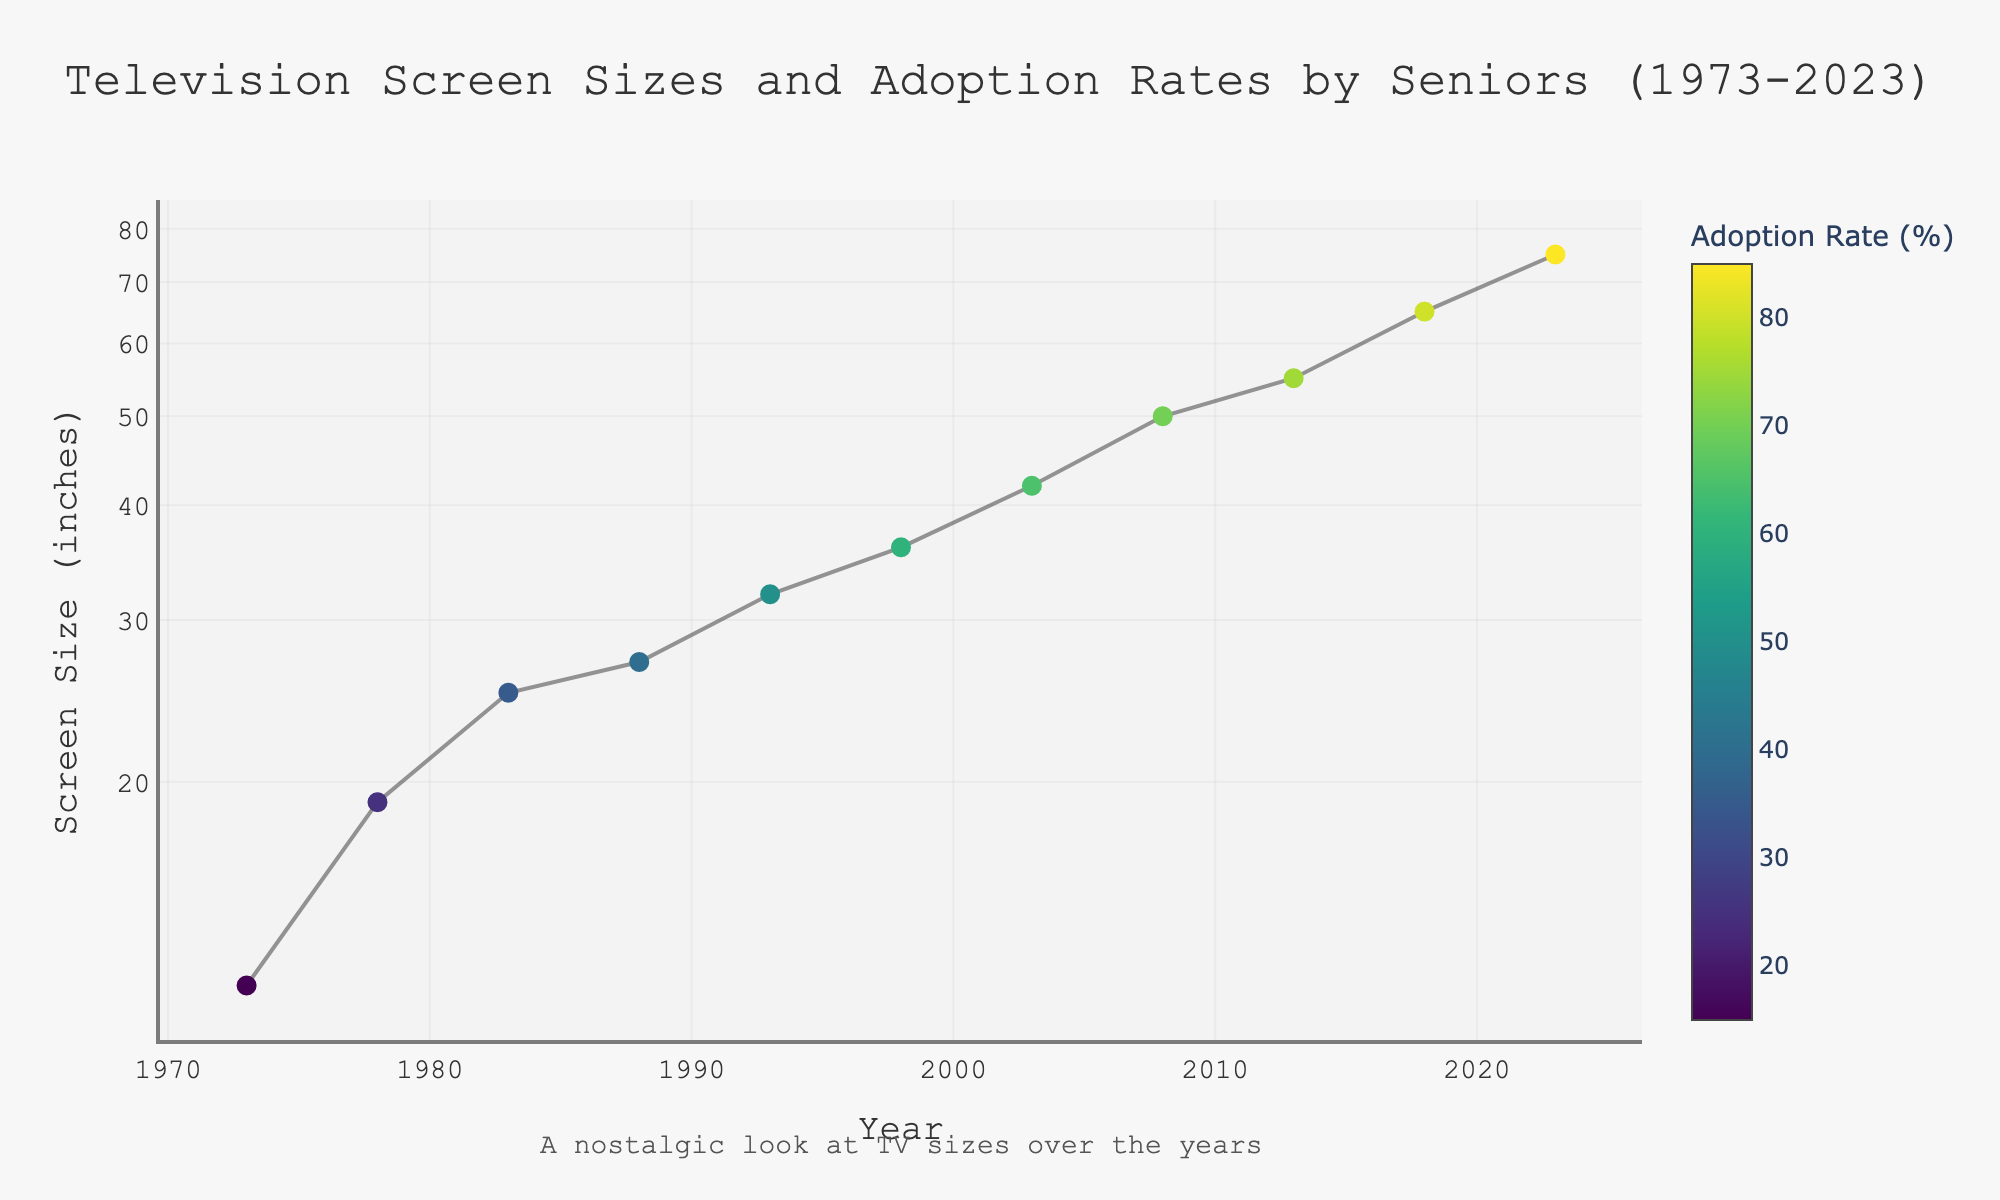what is the smallest screen size shown on the plot? The smallest screen size shown on the plot is the first data point in 1973, which corresponds to 12 inches.
Answer: 12 inches what does the color of the markers represent? The color of the markers represents the adoption rate by seniors, with darker colors indicating lower rates and brighter colors indicating higher rates.
Answer: Adoption rate by seniors how many total data points are shown in the plot? Observing the plot, there is one data point for each year listed, so the total number of data points corresponds to the dataset provided.
Answer: 11 what pattern can be observed between the screen size and the year progression? The plot shows that as the years progress from 1973 to 2023, the screen sizes increase. This indicates a trend of seniors adopting larger television screens over time.
Answer: Screen sizes increase over the years what is the adoption rate of seniors for a 50-inch screen? By locating the data point for a 50-inch screen size, which corresponds to the year 2008, the adoption rate is identified from the plot.
Answer: 70% how much did the screen size increase between 2003 and 2013? The screen size in 2003 is 42 inches and in 2013 is 55 inches. The increase can be calculated as 55 - 42.
Answer: 13 inches compare the adoption rates by seniors in 1978 and 1988. which year had a higher rate? In 1978, the adoption rate is 25%, and in 1988 it is 40%. Thus, 1988 had a higher adoption rate.
Answer: 1988 during which year did the screen size reach 36 inches, and what was the adoption rate by seniors at that time? From the plot, the screen size reached 36 inches in the year 1998, with an adoption rate of 60%.
Answer: 1998, 60% how does the plot title relate to the data presented? The title "Television Screen Sizes and Adoption Rates by Seniors (1973-2023)" accurately describes the content of the plot, which shows the relationship between screen sizes and their adoption rates by seniors over a 50-year span.
Answer: It accurately describes the content what can be inferred about the adoption rate trend as the screen size increases? The plot shows a correlation where the adoption rate by seniors generally increases as the screen size increases, suggesting that seniors have adopted larger screens more over time.
Answer: Adoption rate increases with screen size 